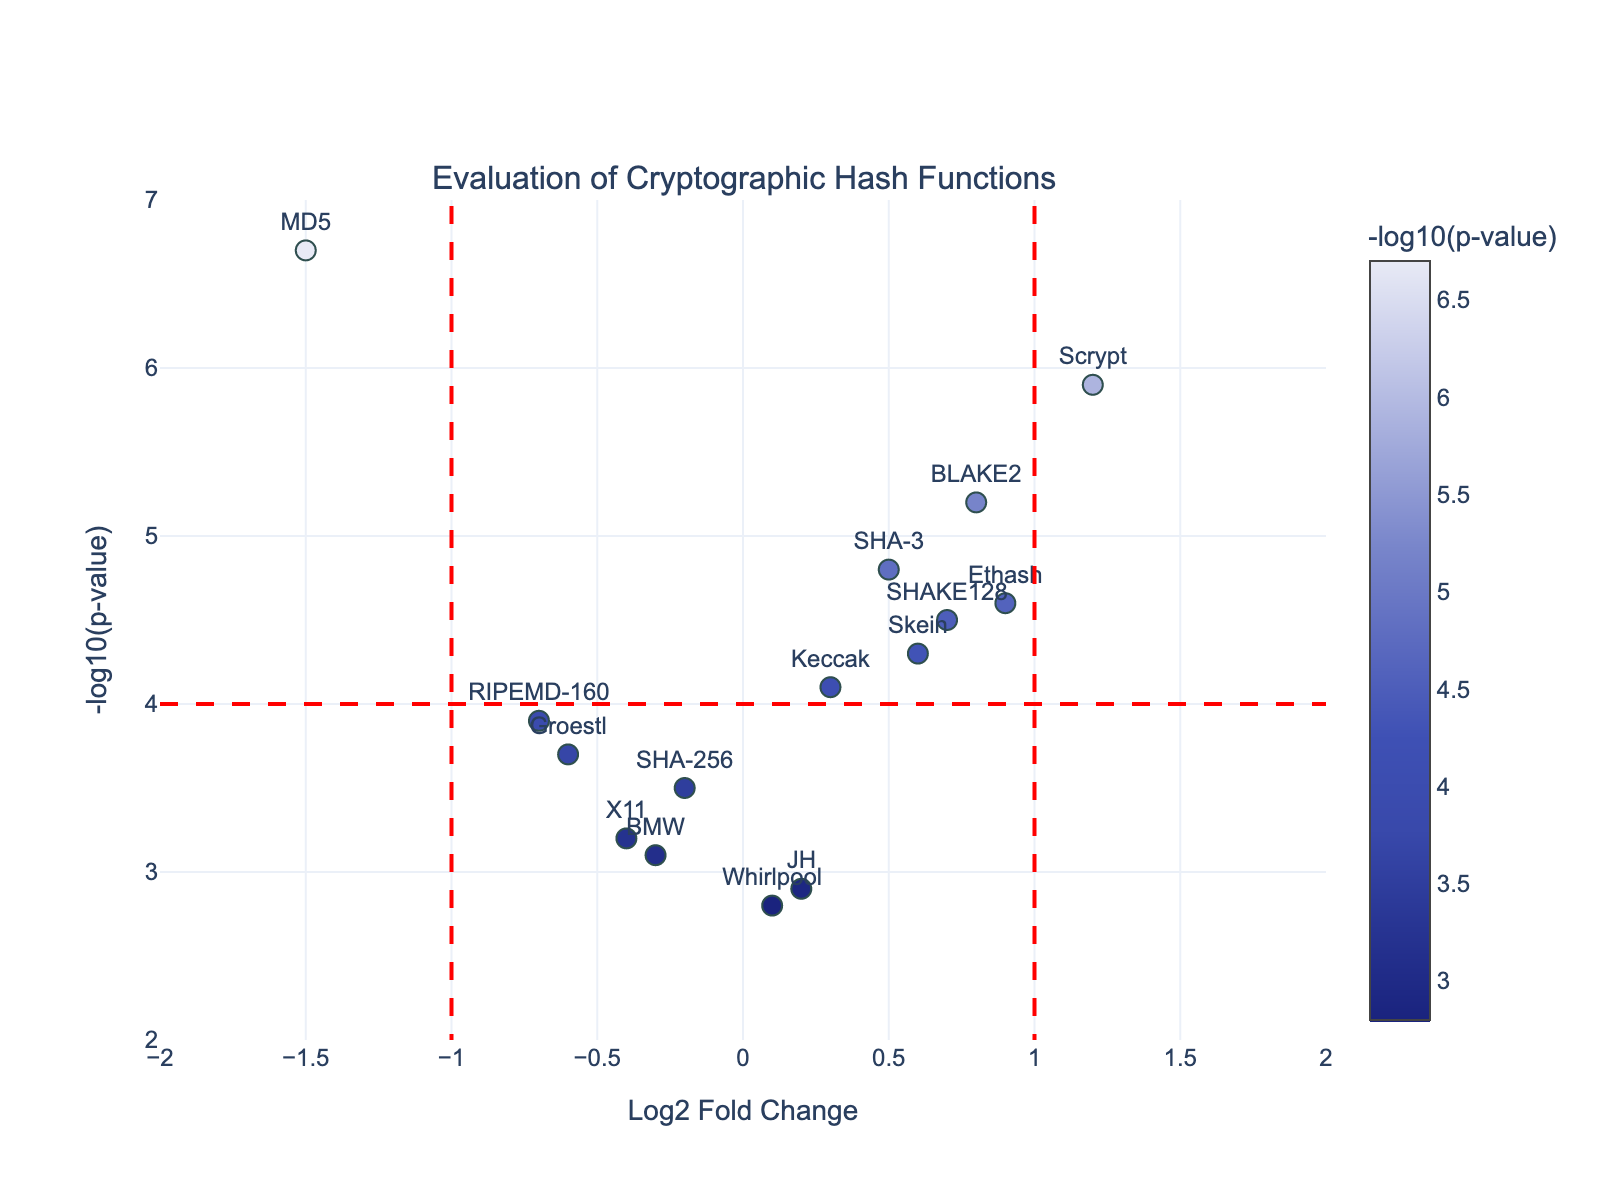What is the title of the volcano plot? The title is located at the top center of the plot. It reads "Evaluation of Cryptographic Hash Functions".
Answer: Evaluation of Cryptographic Hash Functions Which hash function has the highest -log10(p-value)? To find the hash function with the highest -log10(p-value), look for the point with the highest position on the y-axis. It corresponds to MD5 with a -log10(p-value) of 6.7.
Answer: MD5 How many hash functions have a Log2 Fold Change greater than 1? To find this, count the number of points to the right of the vertical line at Log2 Fold Change = 1. Scrypt and Ethash are to the right of this line.
Answer: 2 Which hash functions are marked by the red dashed vertical lines? The red dashed vertical lines are positioned at Log2 Fold Change of -1 and 1. Look for points on or near these lines. No specific hash functions are exactly on these lines, but those close to -1 include SHA-256, RIPEMD-160, and X11.
Answer: SHA-256, RIPEMD-160, X11 What is the Log2 Fold Change and -log10(p-value) of Scrypt? To find Scrypt’s values, look at the specific point labeled “Scrypt” on the plot or refer to the hover information. Scrypt has a Log2 Fold Change of 1.2 and a -log10(p-value) of 5.9.
Answer: 1.2, 5.9 Which hash function has the smallest Log2 Fold Change? To identify the hash function with the smallest Log2 Fold Change, find the point farthest to the left on the x-axis. It corresponds to MD5 with a Log2 Fold Change of -1.5.
Answer: MD5 How many hash functions are above the horizontal red dashed line? The horizontal red dashed line is at -log10(p-value) = 4. Count the points above this line. The hash functions are SHA-3, BLAKE2, MD5, Keccak, Scrypt, Ethash, Skein, and SHAKE128, totaling 8.
Answer: 8 Which hash function has the second highest positive Log2 Fold Change? To determine this, first identify the hash function with the highest positive Log2 Fold Change, which is Scrypt (1.2). The second highest is Ethash with a Log2 Fold Change of 0.9.
Answer: Ethash Compare the -log10(p-value) of BLAKE2 and Keccak. Which one is higher? Compare the y-axis values of BLAKE2 (5.2) and Keccak (4.1). BLAKE2 has a higher -log10(p-value) than Keccak.
Answer: BLAKE2 